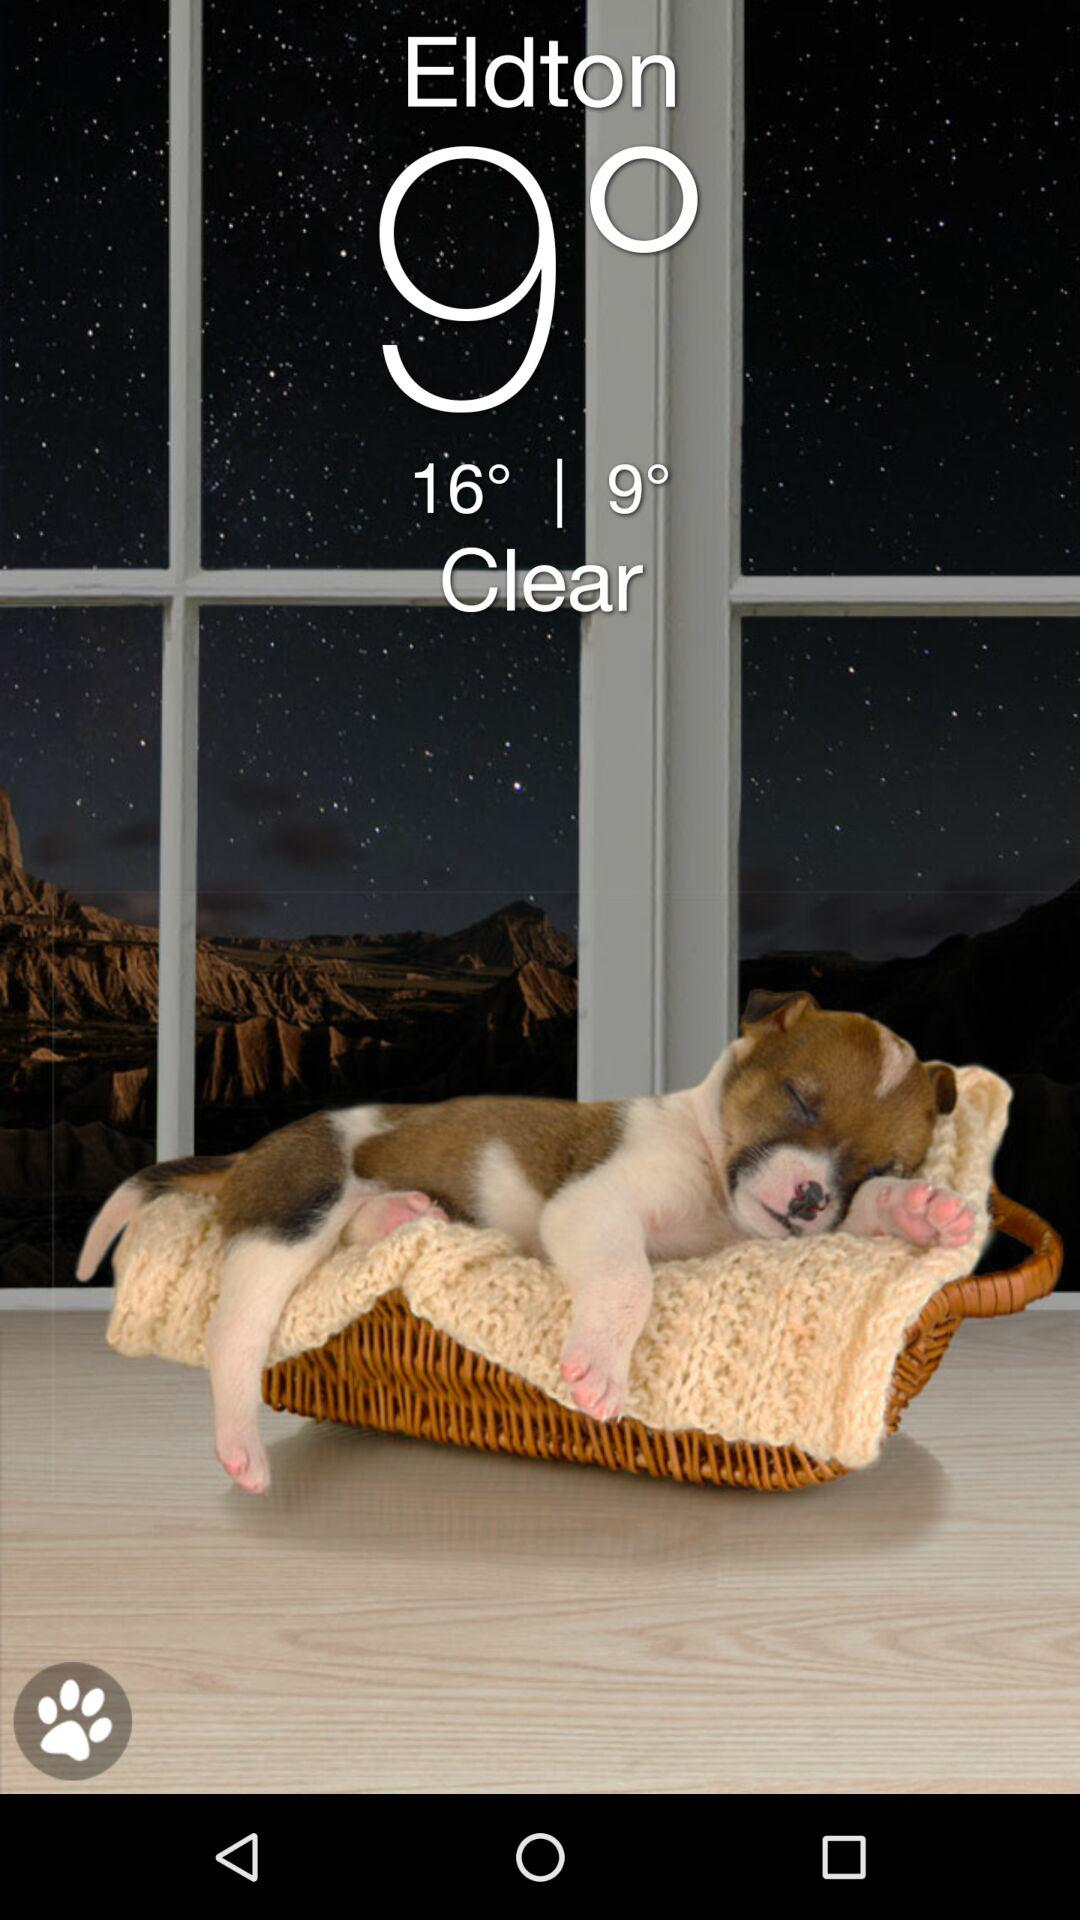How is the weather? The weather is clear. 